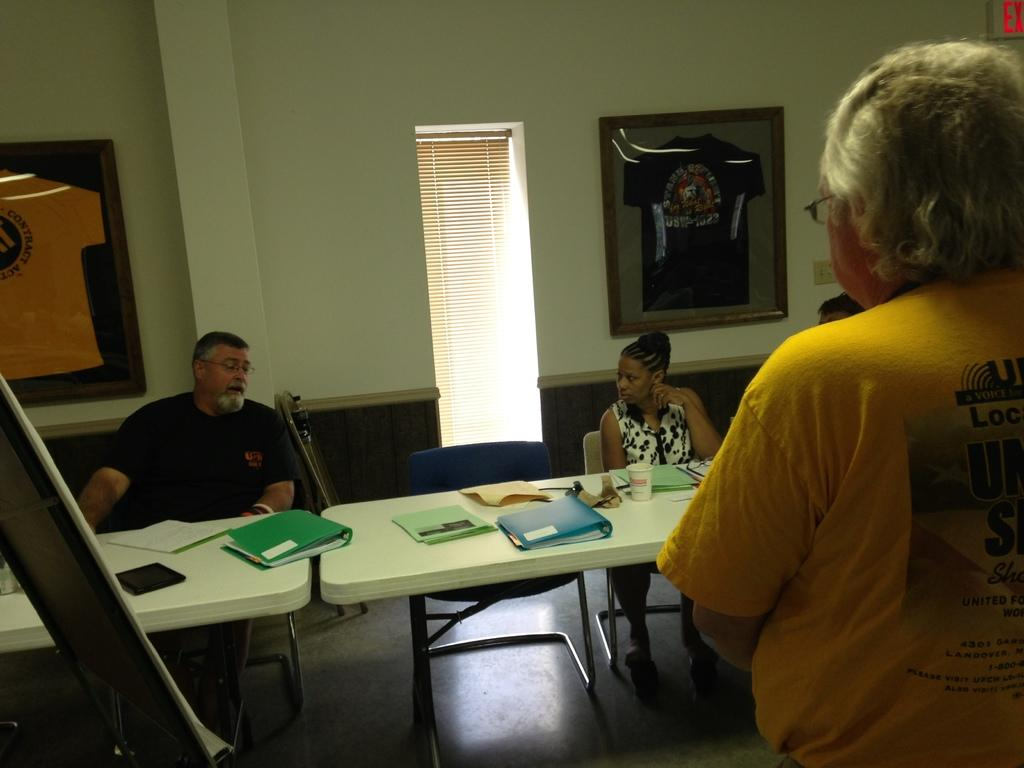What are the people in the image doing? The people in the image are sitting on chairs. What is on the table in the image? There is a full cup and an object on the table. What can be seen on the wall in the image? There is a frame on the wall. What is the position of the person in the image? There is a person standing in the image. What type of test is being conducted in the image? There is no test being conducted in the image; it simply shows people sitting on chairs, a full cup on a table, an object on the table, a frame on the wall, and a person standing. What part of the room is not visible in the image? The image does not show any specific part of the room; it only shows the people, chairs, table, cup, object, frame, and standing person. 